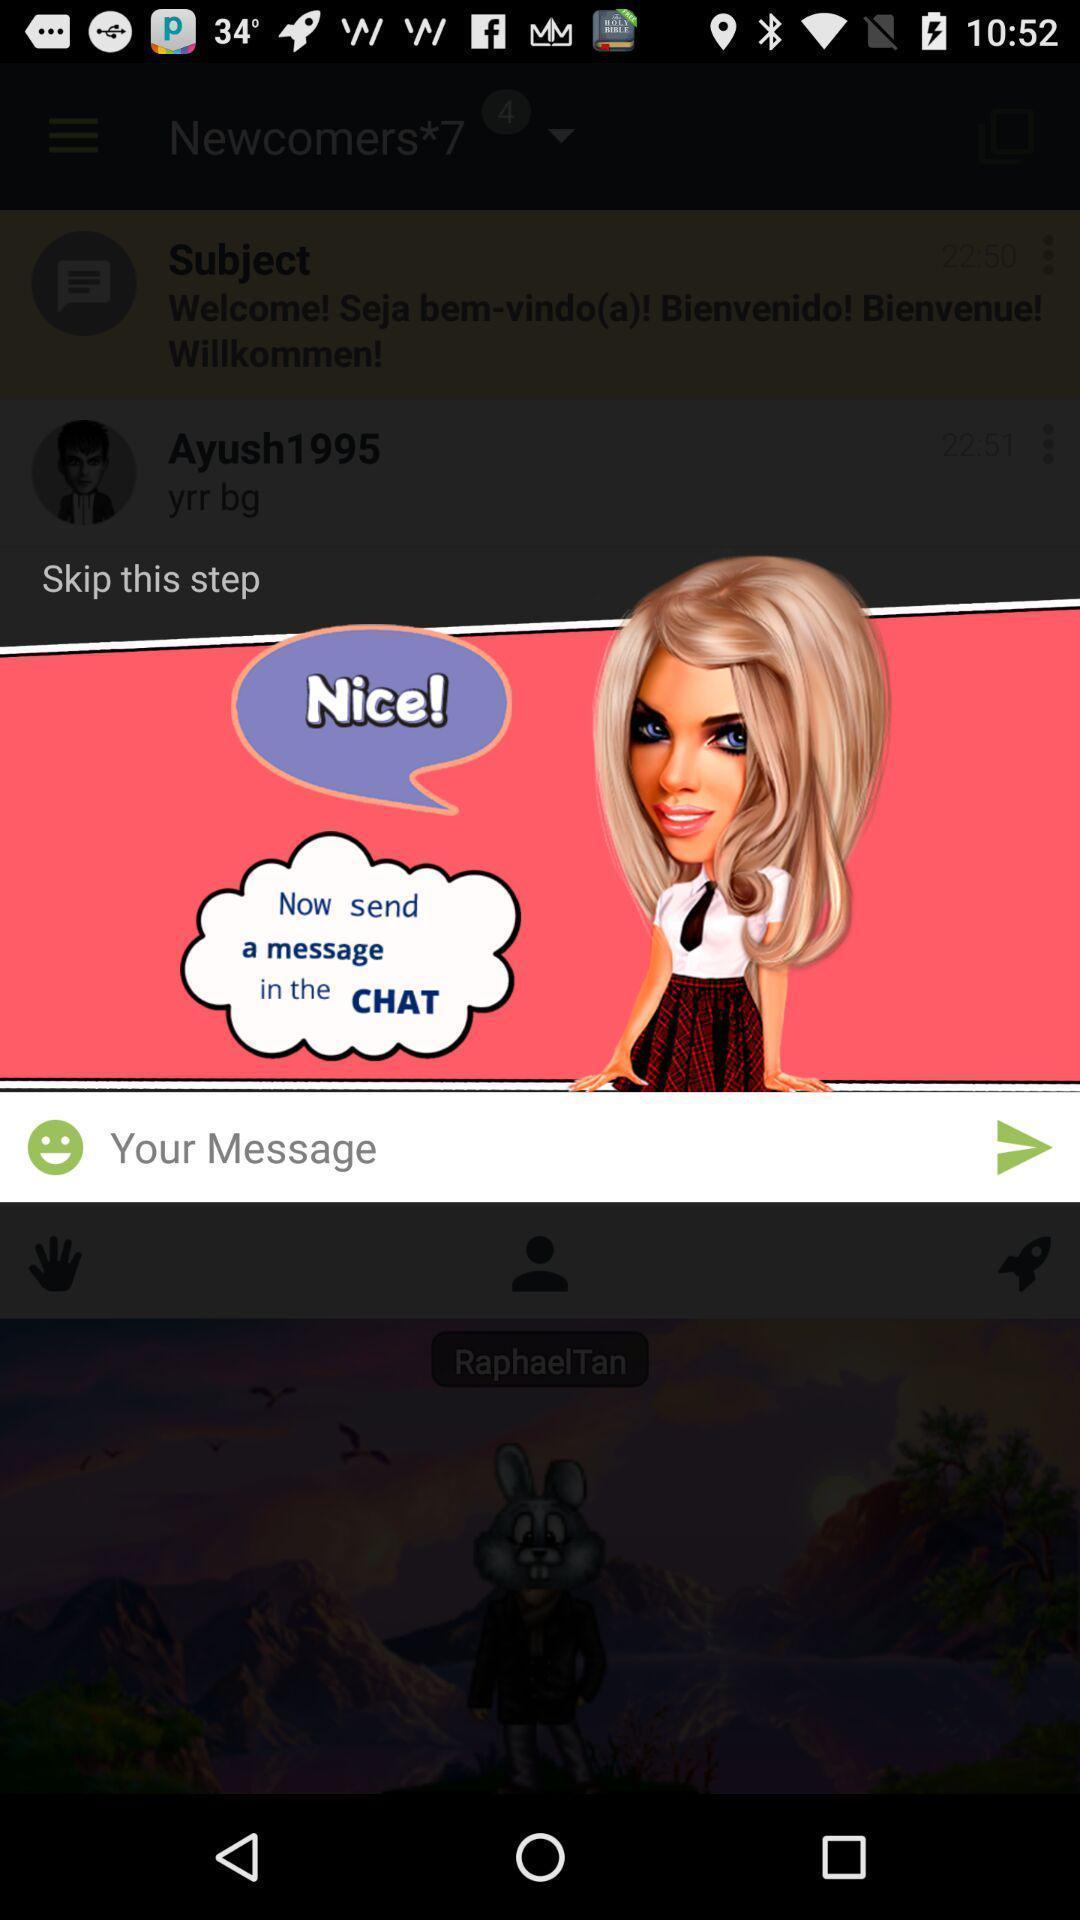Describe the key features of this screenshot. Step in a dating app. 